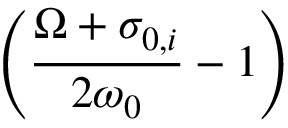<formula> <loc_0><loc_0><loc_500><loc_500>\left ( \frac { \Omega + \sigma _ { 0 , i } } { 2 \omega _ { 0 } } - 1 \right )</formula> 